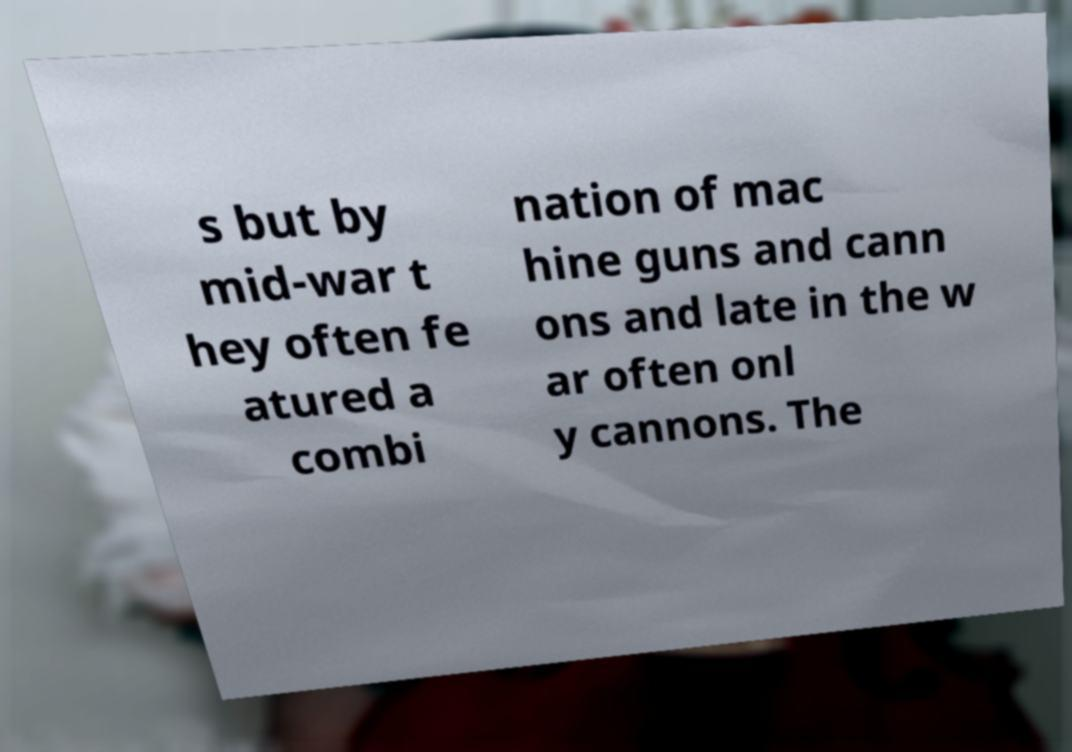I need the written content from this picture converted into text. Can you do that? s but by mid-war t hey often fe atured a combi nation of mac hine guns and cann ons and late in the w ar often onl y cannons. The 